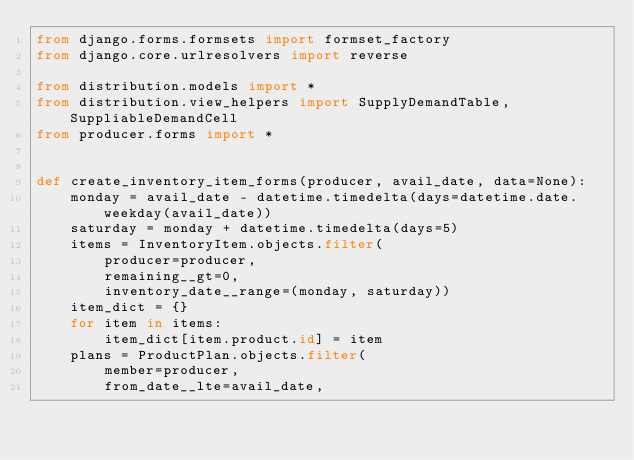Convert code to text. <code><loc_0><loc_0><loc_500><loc_500><_Python_>from django.forms.formsets import formset_factory
from django.core.urlresolvers import reverse

from distribution.models import *
from distribution.view_helpers import SupplyDemandTable, SuppliableDemandCell
from producer.forms import *


def create_inventory_item_forms(producer, avail_date, data=None):
    monday = avail_date - datetime.timedelta(days=datetime.date.weekday(avail_date))
    saturday = monday + datetime.timedelta(days=5)
    items = InventoryItem.objects.filter(
        producer=producer, 
        remaining__gt=0,
        inventory_date__range=(monday, saturday))
    item_dict = {}
    for item in items:
        item_dict[item.product.id] = item
    plans = ProductPlan.objects.filter(
        member=producer, 
        from_date__lte=avail_date, </code> 